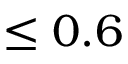<formula> <loc_0><loc_0><loc_500><loc_500>\leq 0 . 6</formula> 